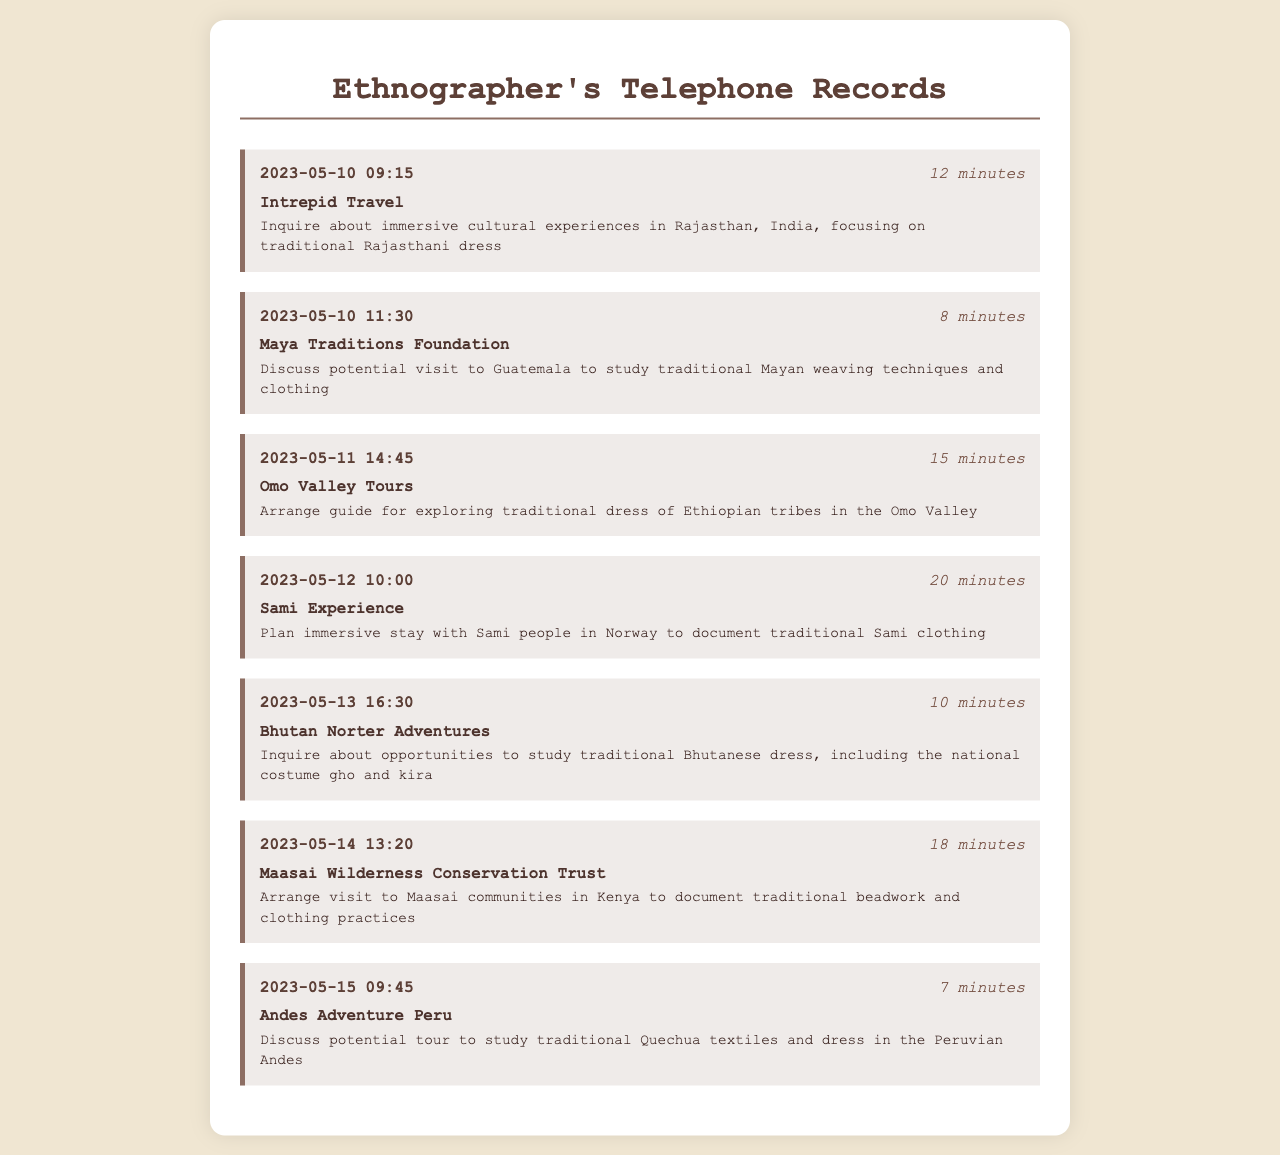what is the date and time of the call to Intrepid Travel? The date and time of the call to Intrepid Travel is listed in the document as 2023-05-10 09:15.
Answer: 2023-05-10 09:15 how long was the call with Maya Traditions Foundation? The duration of the call with Maya Traditions Foundation is mentioned as 8 minutes.
Answer: 8 minutes which organization's services were consulted for traditional dress in the Omo Valley? The organization consulted for traditional dress in the Omo Valley is Omo Valley Tours.
Answer: Omo Valley Tours how many minutes was the call regarding traditional Quechua textiles? The call regarding traditional Quechua textiles lasted for 7 minutes.
Answer: 7 minutes which country was discussed for studying traditional Mayan weaving techniques? The country discussed for studying traditional Mayan weaving techniques is Guatemala.
Answer: Guatemala which cultural group is associated with the call made on May 12? The cultural group associated with the call made on May 12 is the Sami people.
Answer: Sami people what is the primary focus of the inquiry made to Bhutan Norter Adventures? The primary focus of the inquiry made to Bhutan Norter Adventures is traditional Bhutanese dress.
Answer: traditional Bhutanese dress how many minutes long was the call with the Maasai Wilderness Conservation Trust? The call with the Maasai Wilderness Conservation Trust lasted 18 minutes.
Answer: 18 minutes which foundation was approached for experiences related to traditional Rajasthani dress? The foundation approached for experiences related to traditional Rajasthani dress is Intrepid Travel.
Answer: Intrepid Travel 